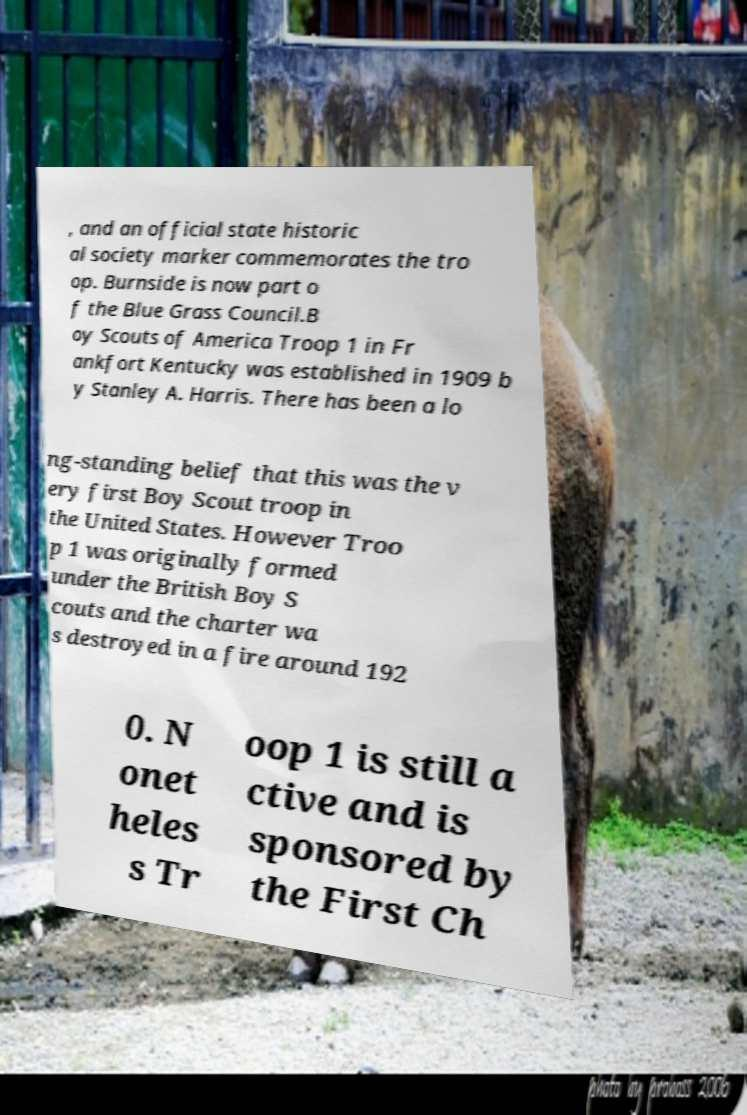Please identify and transcribe the text found in this image. , and an official state historic al society marker commemorates the tro op. Burnside is now part o f the Blue Grass Council.B oy Scouts of America Troop 1 in Fr ankfort Kentucky was established in 1909 b y Stanley A. Harris. There has been a lo ng-standing belief that this was the v ery first Boy Scout troop in the United States. However Troo p 1 was originally formed under the British Boy S couts and the charter wa s destroyed in a fire around 192 0. N onet heles s Tr oop 1 is still a ctive and is sponsored by the First Ch 